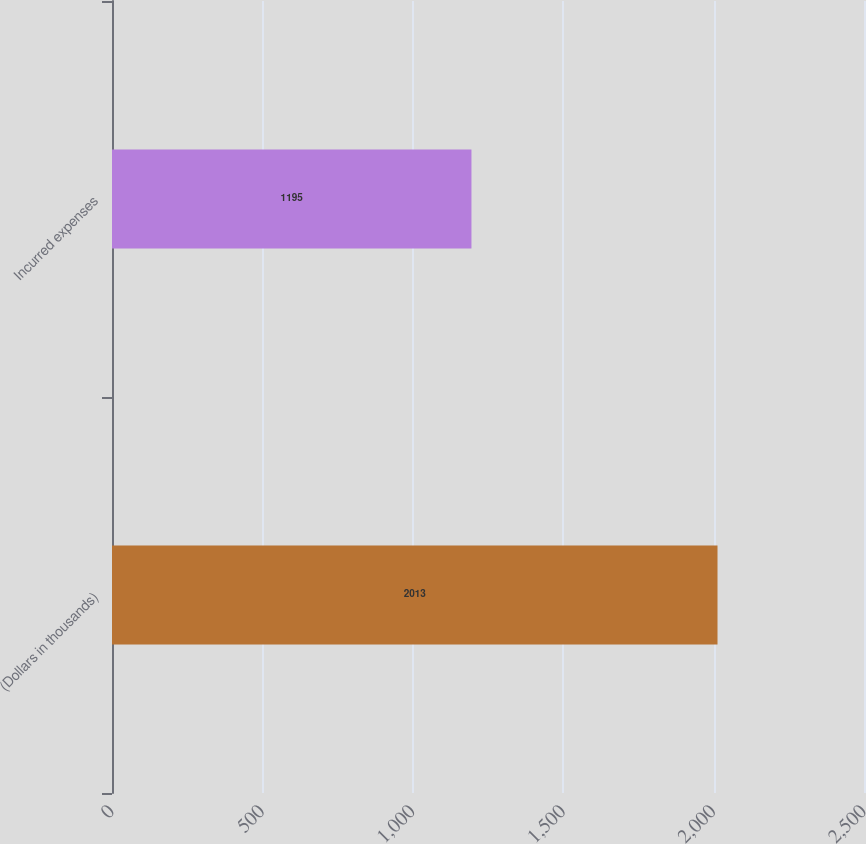<chart> <loc_0><loc_0><loc_500><loc_500><bar_chart><fcel>(Dollars in thousands)<fcel>Incurred expenses<nl><fcel>2013<fcel>1195<nl></chart> 